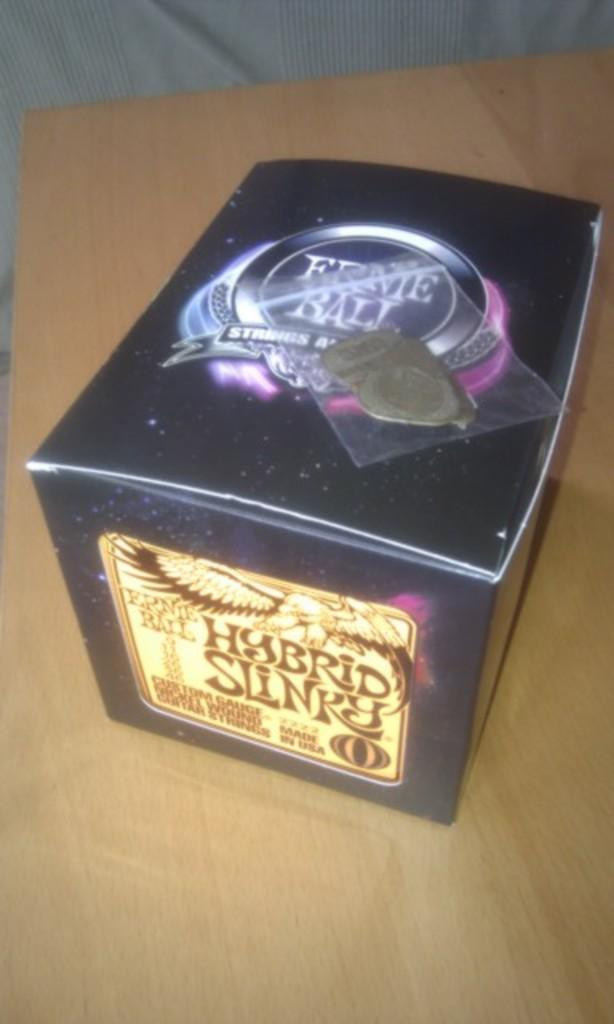<image>
Relay a brief, clear account of the picture shown. A box of Ernie Ball custom gauge guitar strings. 